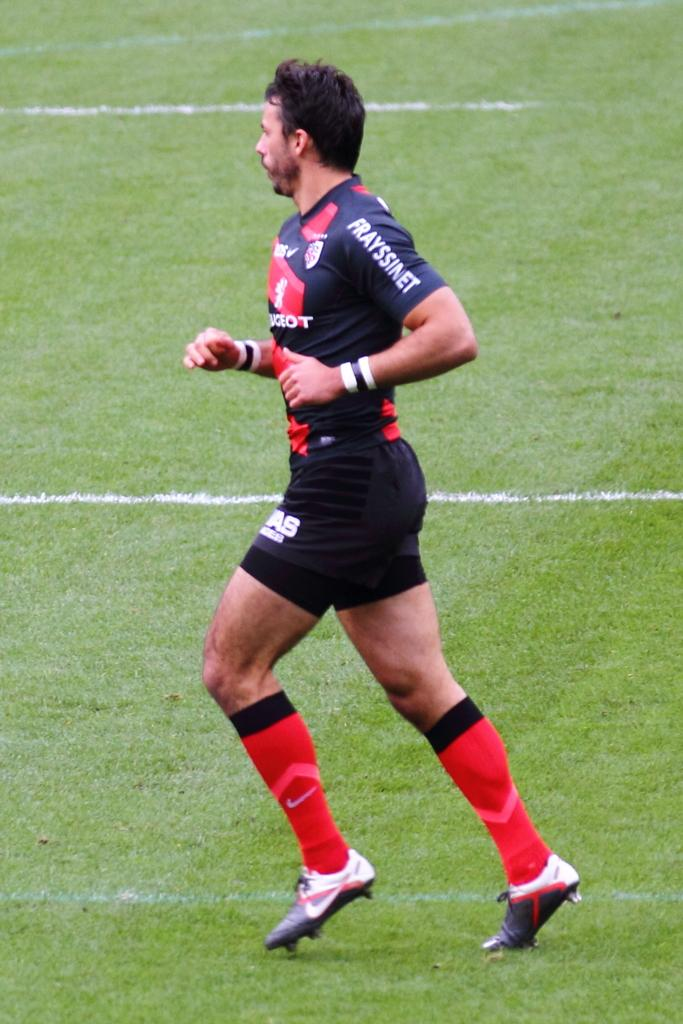Who is the main subject in the image? There is a person in the image. What is the person doing in the image? The person is running. What type of terrain is the person running on? The person is running on a grassy land. What type of teeth can be seen in the image? There are no teeth visible in the image, as it features a person running on a grassy land. 